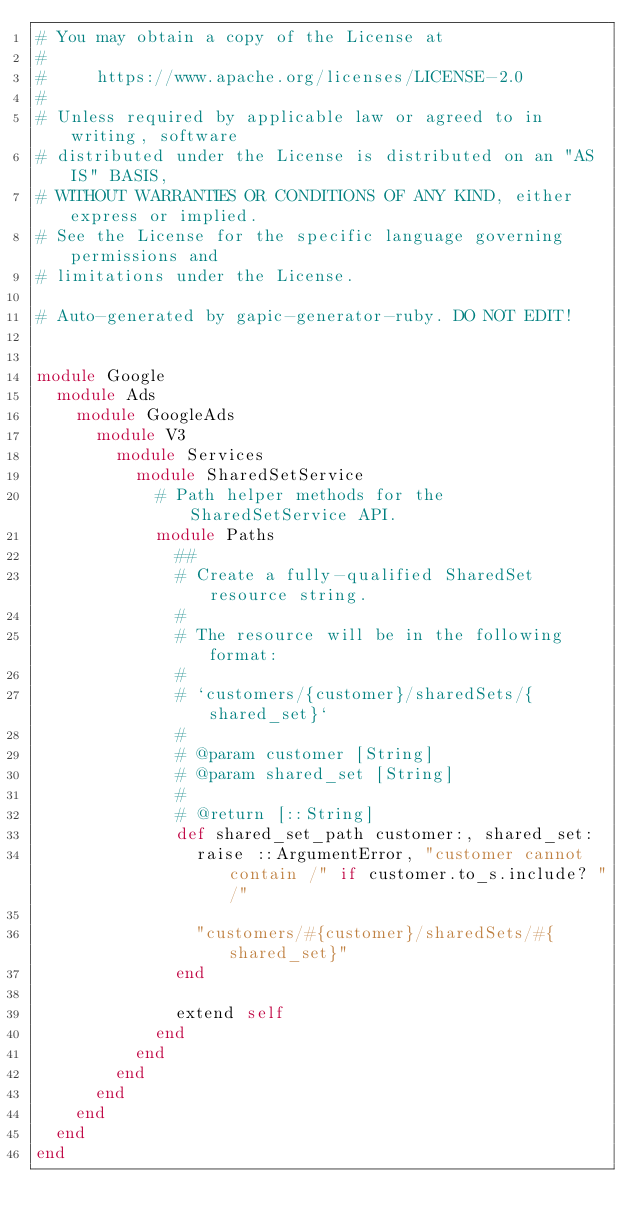Convert code to text. <code><loc_0><loc_0><loc_500><loc_500><_Ruby_># You may obtain a copy of the License at
#
#     https://www.apache.org/licenses/LICENSE-2.0
#
# Unless required by applicable law or agreed to in writing, software
# distributed under the License is distributed on an "AS IS" BASIS,
# WITHOUT WARRANTIES OR CONDITIONS OF ANY KIND, either express or implied.
# See the License for the specific language governing permissions and
# limitations under the License.

# Auto-generated by gapic-generator-ruby. DO NOT EDIT!


module Google
  module Ads
    module GoogleAds
      module V3
        module Services
          module SharedSetService
            # Path helper methods for the SharedSetService API.
            module Paths
              ##
              # Create a fully-qualified SharedSet resource string.
              #
              # The resource will be in the following format:
              #
              # `customers/{customer}/sharedSets/{shared_set}`
              #
              # @param customer [String]
              # @param shared_set [String]
              #
              # @return [::String]
              def shared_set_path customer:, shared_set:
                raise ::ArgumentError, "customer cannot contain /" if customer.to_s.include? "/"

                "customers/#{customer}/sharedSets/#{shared_set}"
              end

              extend self
            end
          end
        end
      end
    end
  end
end

</code> 